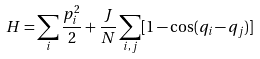Convert formula to latex. <formula><loc_0><loc_0><loc_500><loc_500>H = \sum _ { i } \frac { p _ { i } ^ { 2 } } { 2 } + \frac { J } { N } \sum _ { i , j } [ 1 - \cos ( q _ { i } - q _ { j } ) ]</formula> 